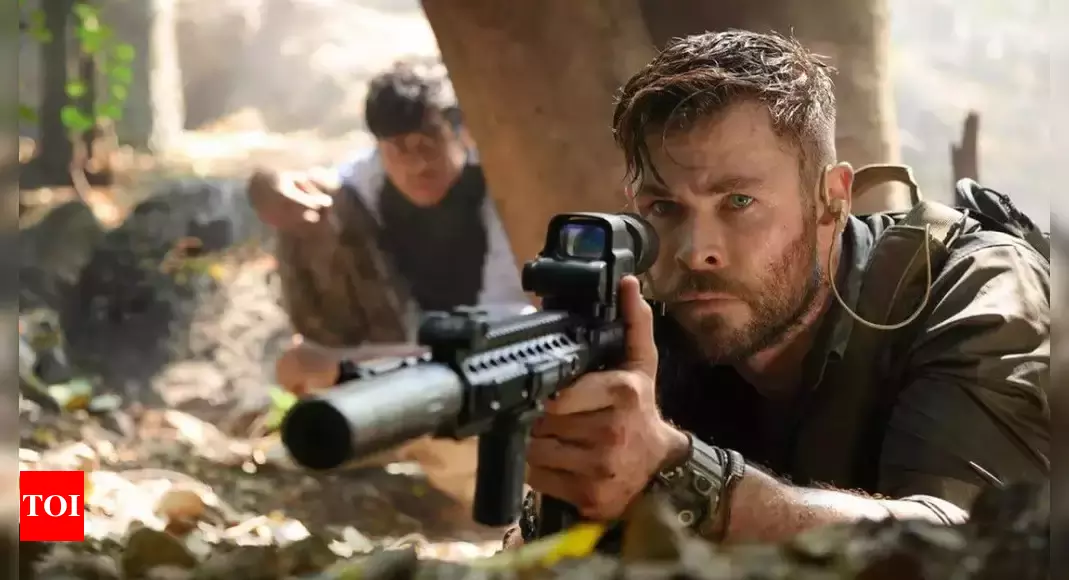Can you describe the atmosphere of the setting in this image? The atmosphere in this image is one of intense tension and suspense. The dense jungle or forest setting lends a sense of isolation and unpredictability. The dappled sunlight filtering through the foliage creates stark contrasts, emphasizing the danger that the characters face. The expressions and body language of the two central figures suggest they are on high alert, ready for any imminent threat. Overall, the setting enhances the feeling of urgency and the gravity of their situation. 